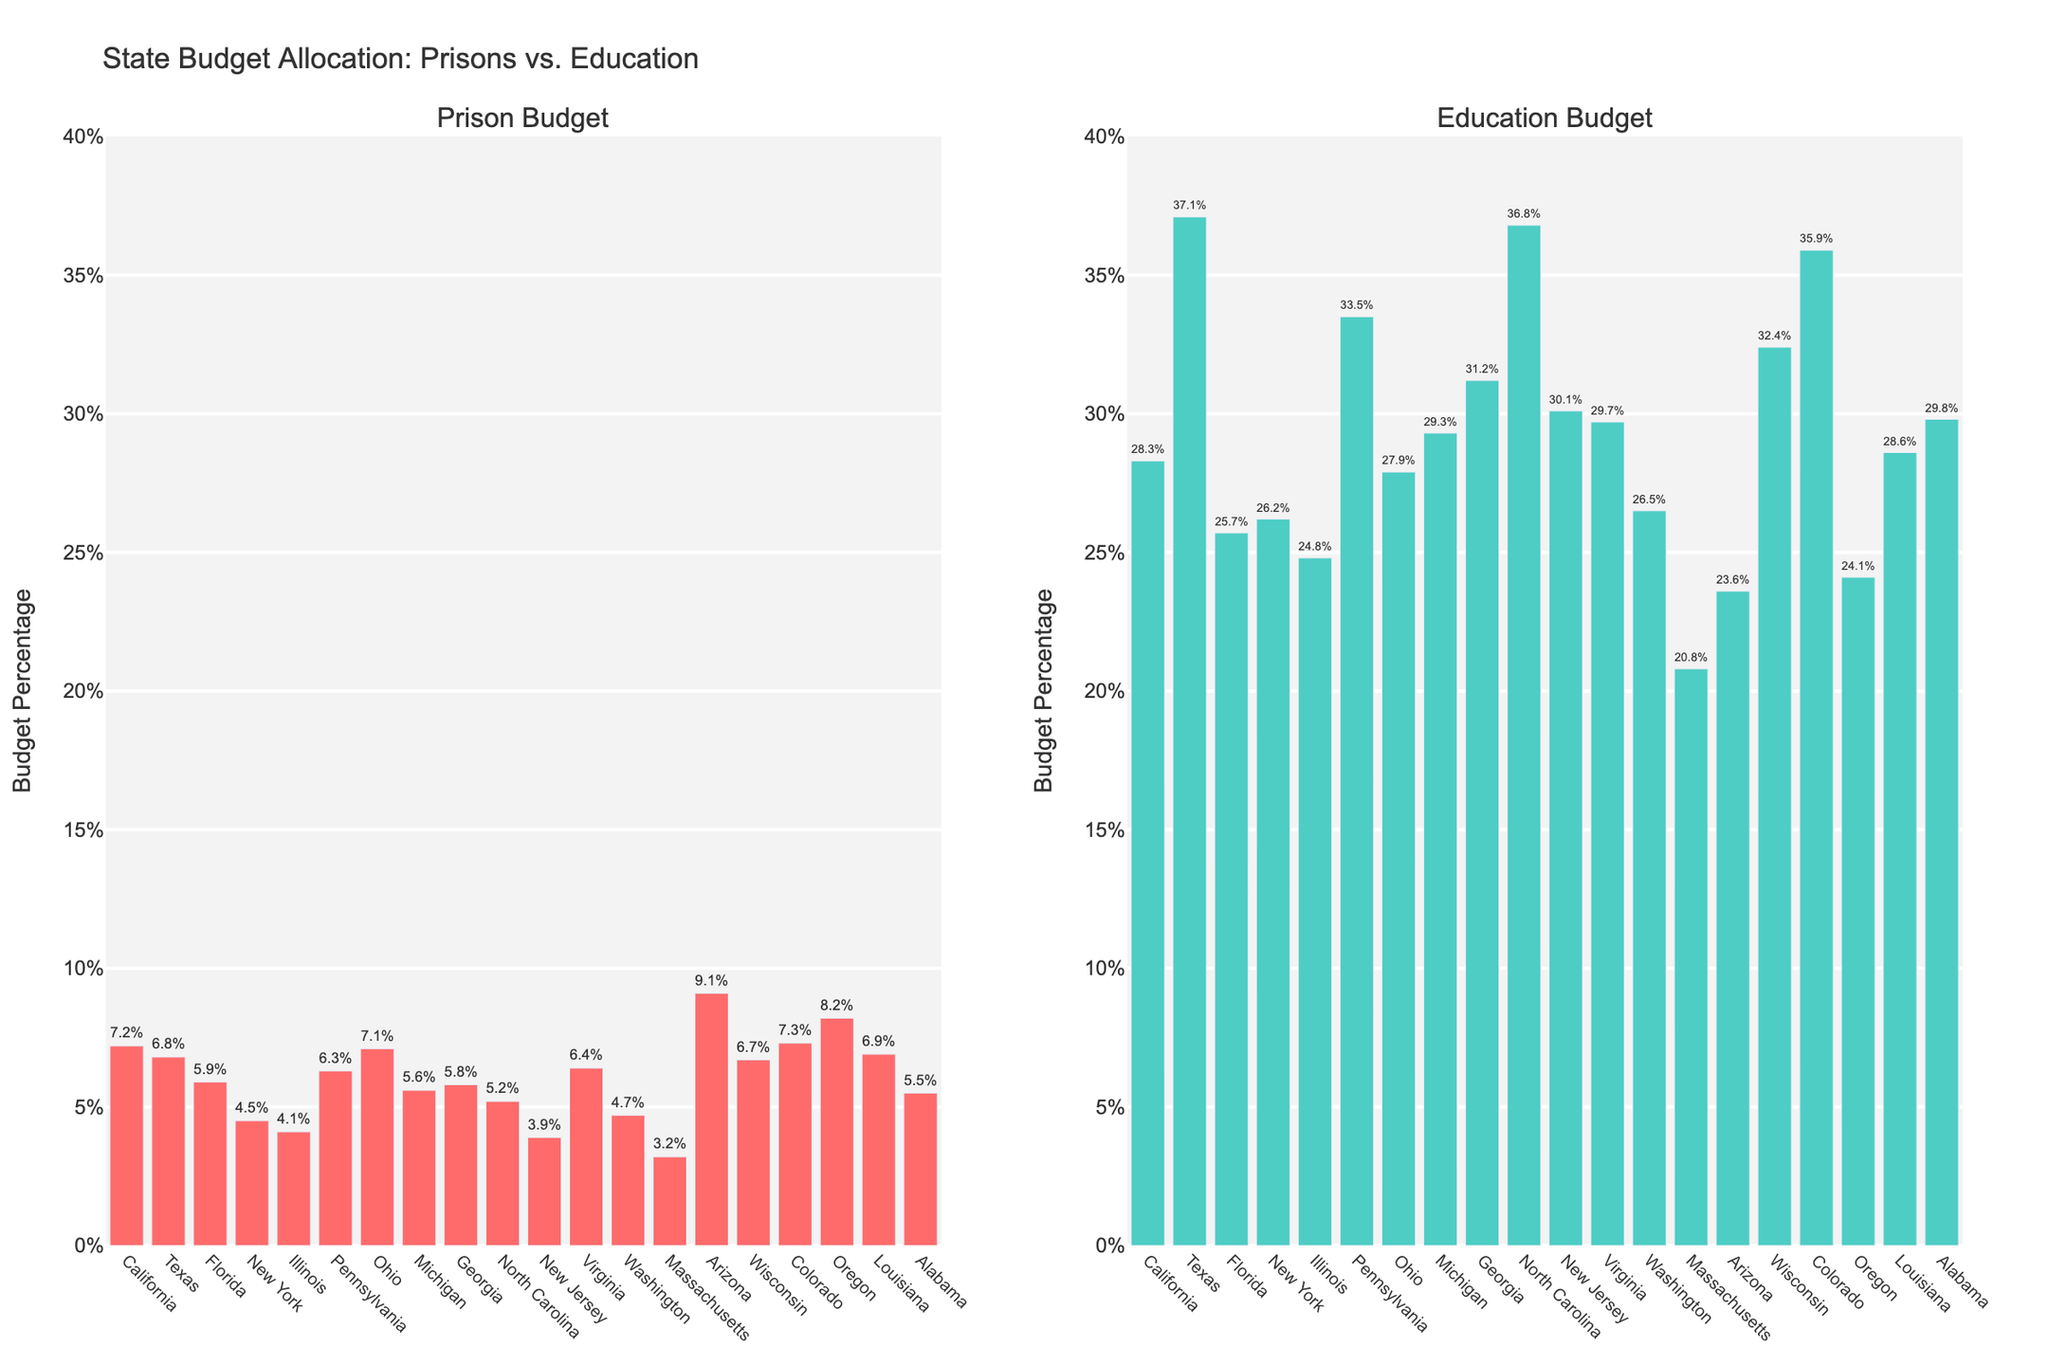Which state allocates the highest percentage of its budget to prisons? By visually assessing the height of the bars in the Prison Budget chart, we see that Arizona's bar is the tallest.
Answer: Arizona Which state allocates the highest percentage of its budget to education? By examining the height of the bars in the Education Budget chart, we see that Texas's bar is the tallest.
Answer: Texas What is the difference between the prison budget and education budget in Massachusetts? In the plot, the prison budget for Massachusetts is 3.2% and the education budget is 20.8%. The difference is 20.8% - 3.2% = 17.6%.
Answer: 17.6% Which state has a greater allocation for prisons, California or Ohio? By comparing the heights of the bars for each state in the Prison Budget chart, California has 7.2% and Ohio has 7.1%. California allocates more.
Answer: California What is the combined budget percentage for education in New Jersey, Georgia, and Alabama? From the Education Budget chart, New Jersey has 30.1%, Georgia has 31.2%, and Alabama has 29.8%. Adding these values: 30.1% + 31.2% + 29.8% = 91.1%.
Answer: 91.1% What is the average prison budget percentage for Arizona, Oregon, and Texas? From the Prison Budget chart, Arizona has 9.1%, Oregon has 8.2%, and Texas has 6.8%. The average is calculated as (9.1% + 8.2% + 6.8%) / 3 = 8.03%.
Answer: 8.03% Which budget allocation is higher in Colorado, prison or education? By comparing the heights of the bars for Colorado, the prison budget is 7.3% and the education budget is 35.9%. The education budget is higher.
Answer: Education By how much does Florida's education budget exceed its prison budget? From the bar heights, Florida's education budget is 25.7% and its prison budget is 5.9%. The difference is 25.7% - 5.9% = 19.8%.
Answer: 19.8% Identify two states where the education budget allocation is more than six times the prison budget allocation? By comparing the ratios of the education to prison budgets, Massachusetts (20.8% / 3.2% = 6.5) and North Carolina (36.8% / 5.2% = 7.08) both meet this condition.
Answer: Massachusetts, North Carolina 